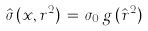<formula> <loc_0><loc_0><loc_500><loc_500>\hat { \sigma } \, ( x , r ^ { 2 } ) \, = \, \sigma _ { 0 } \, g \, ( \hat { r } ^ { 2 } )</formula> 